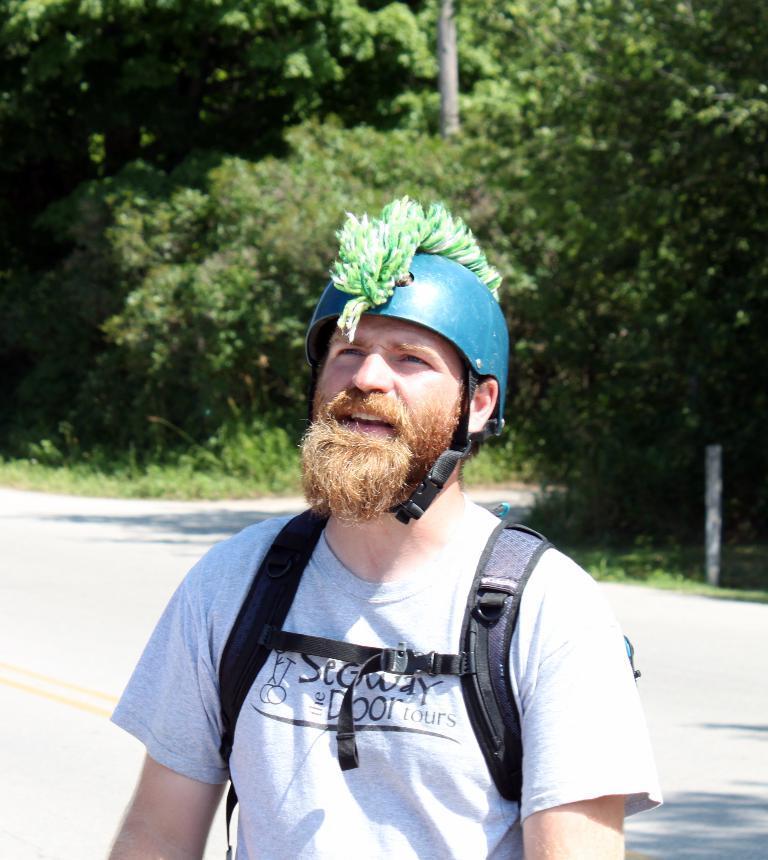Please provide a concise description of this image. In this picture we can see a man wore a helmet and carrying a bag and in the background we can see the road, poles, trees. 